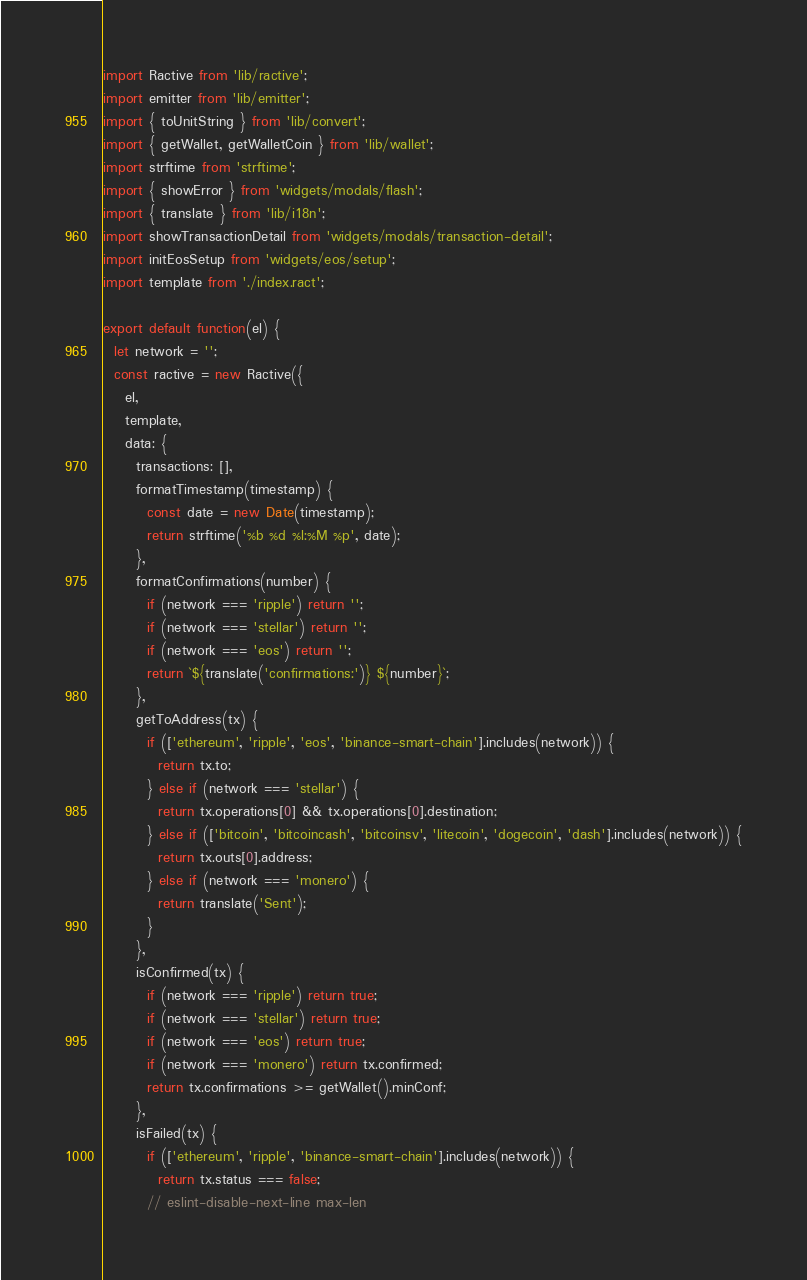Convert code to text. <code><loc_0><loc_0><loc_500><loc_500><_JavaScript_>import Ractive from 'lib/ractive';
import emitter from 'lib/emitter';
import { toUnitString } from 'lib/convert';
import { getWallet, getWalletCoin } from 'lib/wallet';
import strftime from 'strftime';
import { showError } from 'widgets/modals/flash';
import { translate } from 'lib/i18n';
import showTransactionDetail from 'widgets/modals/transaction-detail';
import initEosSetup from 'widgets/eos/setup';
import template from './index.ract';

export default function(el) {
  let network = '';
  const ractive = new Ractive({
    el,
    template,
    data: {
      transactions: [],
      formatTimestamp(timestamp) {
        const date = new Date(timestamp);
        return strftime('%b %d %l:%M %p', date);
      },
      formatConfirmations(number) {
        if (network === 'ripple') return '';
        if (network === 'stellar') return '';
        if (network === 'eos') return '';
        return `${translate('confirmations:')} ${number}`;
      },
      getToAddress(tx) {
        if (['ethereum', 'ripple', 'eos', 'binance-smart-chain'].includes(network)) {
          return tx.to;
        } else if (network === 'stellar') {
          return tx.operations[0] && tx.operations[0].destination;
        } else if (['bitcoin', 'bitcoincash', 'bitcoinsv', 'litecoin', 'dogecoin', 'dash'].includes(network)) {
          return tx.outs[0].address;
        } else if (network === 'monero') {
          return translate('Sent');
        }
      },
      isConfirmed(tx) {
        if (network === 'ripple') return true;
        if (network === 'stellar') return true;
        if (network === 'eos') return true;
        if (network === 'monero') return tx.confirmed;
        return tx.confirmations >= getWallet().minConf;
      },
      isFailed(tx) {
        if (['ethereum', 'ripple', 'binance-smart-chain'].includes(network)) {
          return tx.status === false;
        // eslint-disable-next-line max-len</code> 